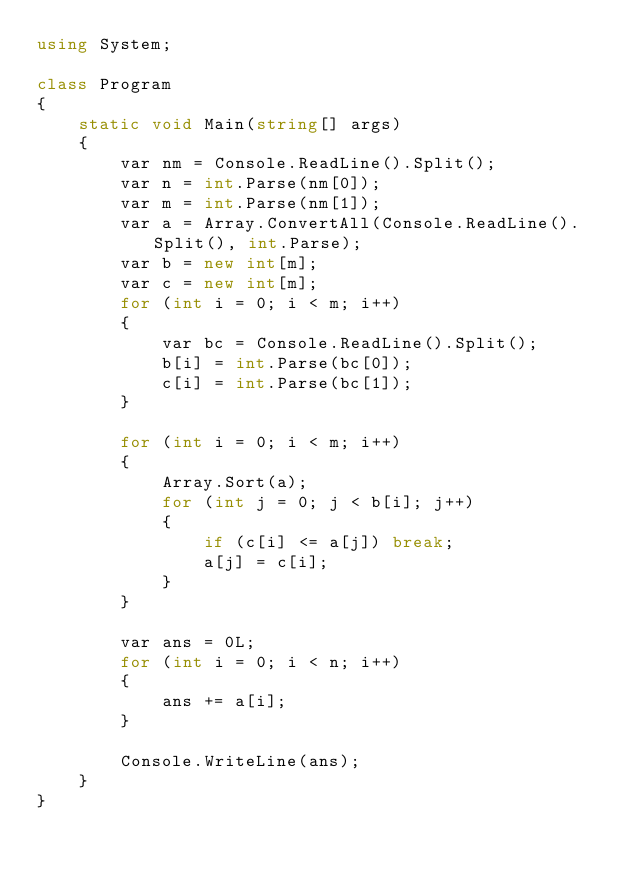<code> <loc_0><loc_0><loc_500><loc_500><_C#_>using System;

class Program
{
    static void Main(string[] args)
    {
        var nm = Console.ReadLine().Split();
        var n = int.Parse(nm[0]);
        var m = int.Parse(nm[1]);
        var a = Array.ConvertAll(Console.ReadLine().Split(), int.Parse);
        var b = new int[m];
        var c = new int[m];
        for (int i = 0; i < m; i++)
        {
            var bc = Console.ReadLine().Split();
            b[i] = int.Parse(bc[0]);
            c[i] = int.Parse(bc[1]);
        }

        for (int i = 0; i < m; i++)
        {
            Array.Sort(a);
            for (int j = 0; j < b[i]; j++)
            {
                if (c[i] <= a[j]) break;
                a[j] = c[i];
            }
        }

        var ans = 0L;
        for (int i = 0; i < n; i++)
        {
            ans += a[i];
        }

        Console.WriteLine(ans);
    }
}
</code> 